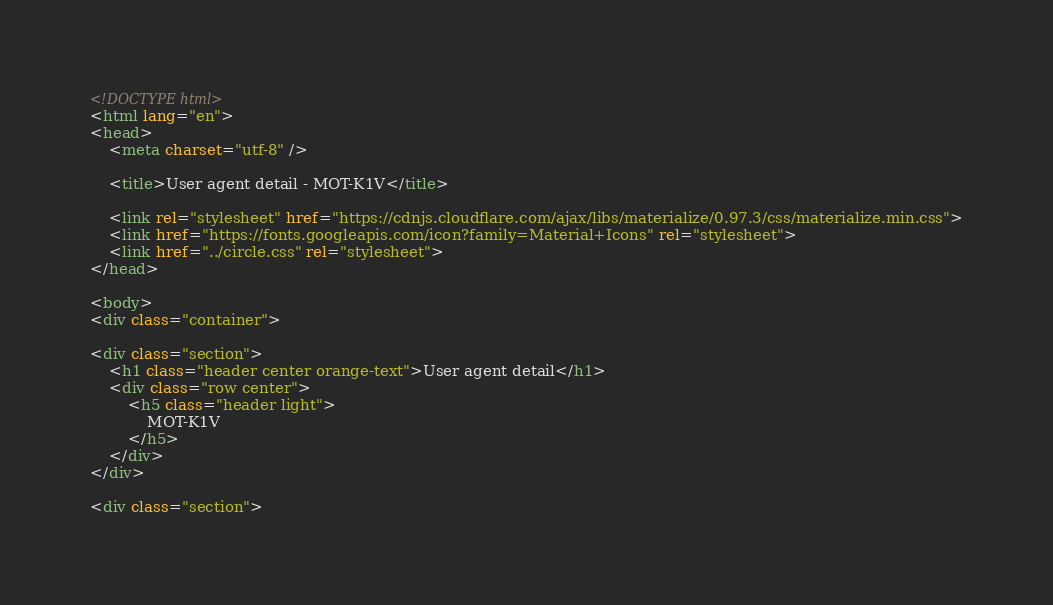Convert code to text. <code><loc_0><loc_0><loc_500><loc_500><_HTML_>
<!DOCTYPE html>
<html lang="en">
<head>
    <meta charset="utf-8" />
            
    <title>User agent detail - MOT-K1V</title>
        
    <link rel="stylesheet" href="https://cdnjs.cloudflare.com/ajax/libs/materialize/0.97.3/css/materialize.min.css">
    <link href="https://fonts.googleapis.com/icon?family=Material+Icons" rel="stylesheet">
    <link href="../circle.css" rel="stylesheet">
</head>
        
<body>
<div class="container">
    
<div class="section">
	<h1 class="header center orange-text">User agent detail</h1>
	<div class="row center">
        <h5 class="header light">
            MOT-K1V
        </h5>
	</div>
</div>   

<div class="section"></code> 